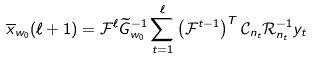<formula> <loc_0><loc_0><loc_500><loc_500>\overline { x } _ { w _ { 0 } } ( \ell + 1 ) = \mathcal { F } ^ { \ell } \widetilde { G } _ { w _ { 0 } } ^ { - 1 } \sum _ { t = 1 } ^ { \ell } \left ( \mathcal { F } ^ { t - 1 } \right ) ^ { T } \mathcal { C } _ { n _ { t } } \mathcal { R } _ { n _ { t } } ^ { - 1 } y _ { t }</formula> 